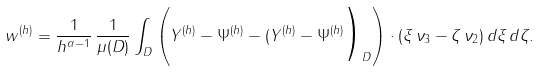Convert formula to latex. <formula><loc_0><loc_0><loc_500><loc_500>w ^ { ( h ) } = \frac { 1 } { h ^ { \alpha - 1 } } \, \frac { 1 } { \mu ( D ) } \int _ { D } \left ( Y ^ { ( h ) } - \Psi ^ { ( h ) } - ( Y ^ { ( h ) } - \Psi ^ { ( h ) } \Big ) _ { D } \right ) \cdot ( \xi \, \nu _ { 3 } - \zeta \, \nu _ { 2 } ) \, d \xi \, d \zeta .</formula> 